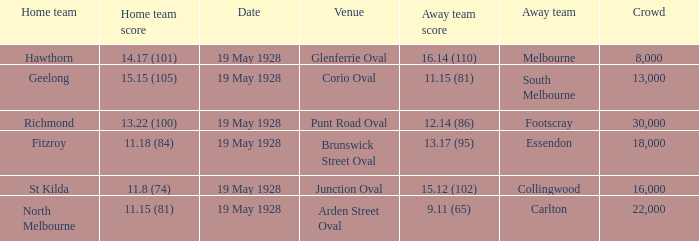What is the listed crowd when essendon is the away squad? 1.0. 